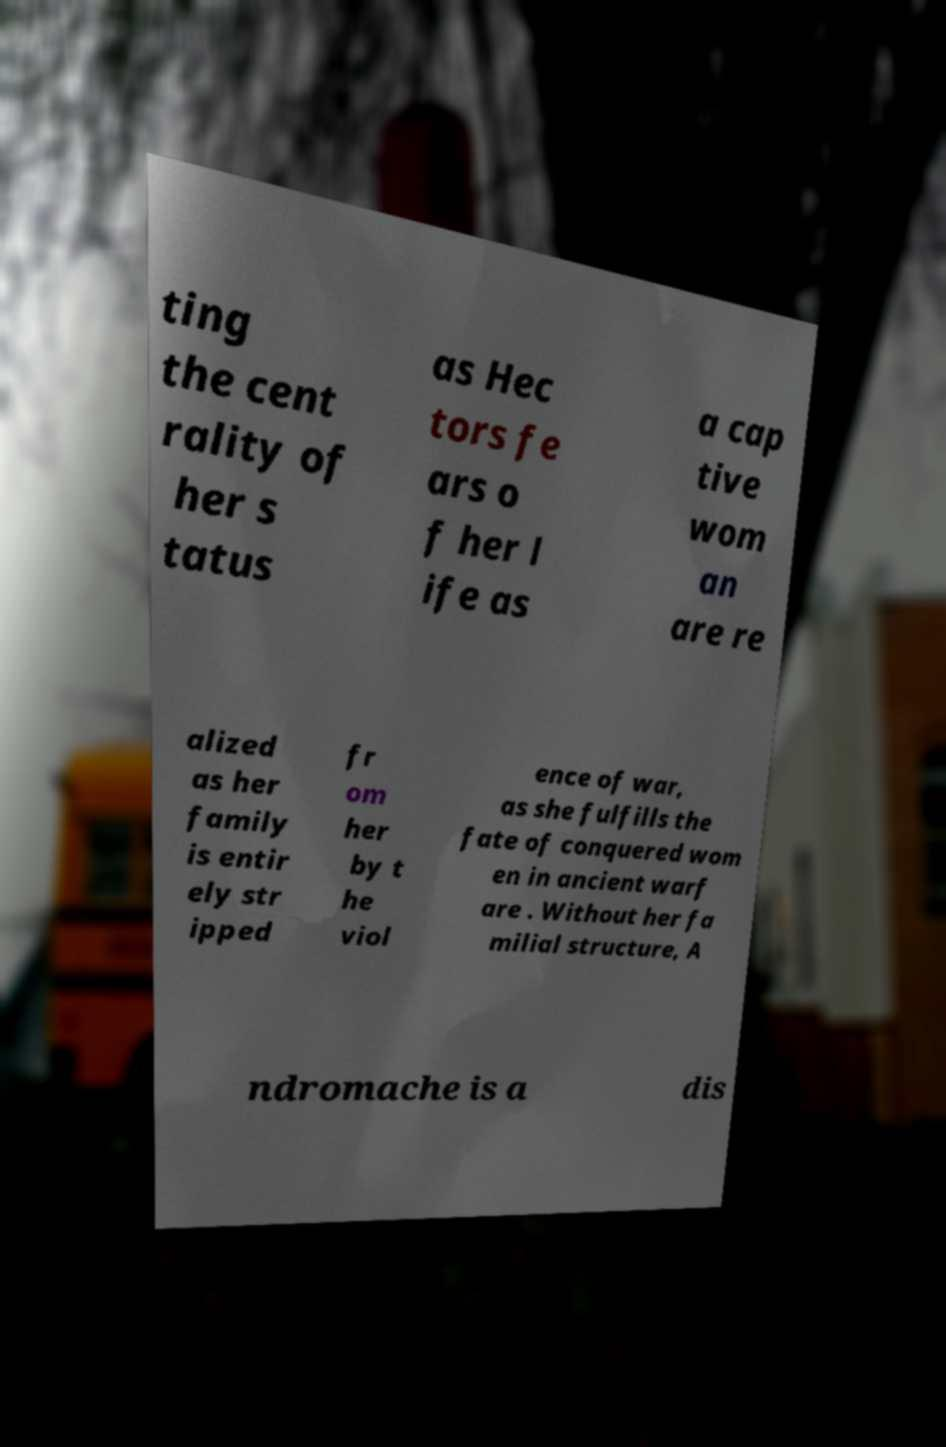Could you assist in decoding the text presented in this image and type it out clearly? ting the cent rality of her s tatus as Hec tors fe ars o f her l ife as a cap tive wom an are re alized as her family is entir ely str ipped fr om her by t he viol ence of war, as she fulfills the fate of conquered wom en in ancient warf are . Without her fa milial structure, A ndromache is a dis 